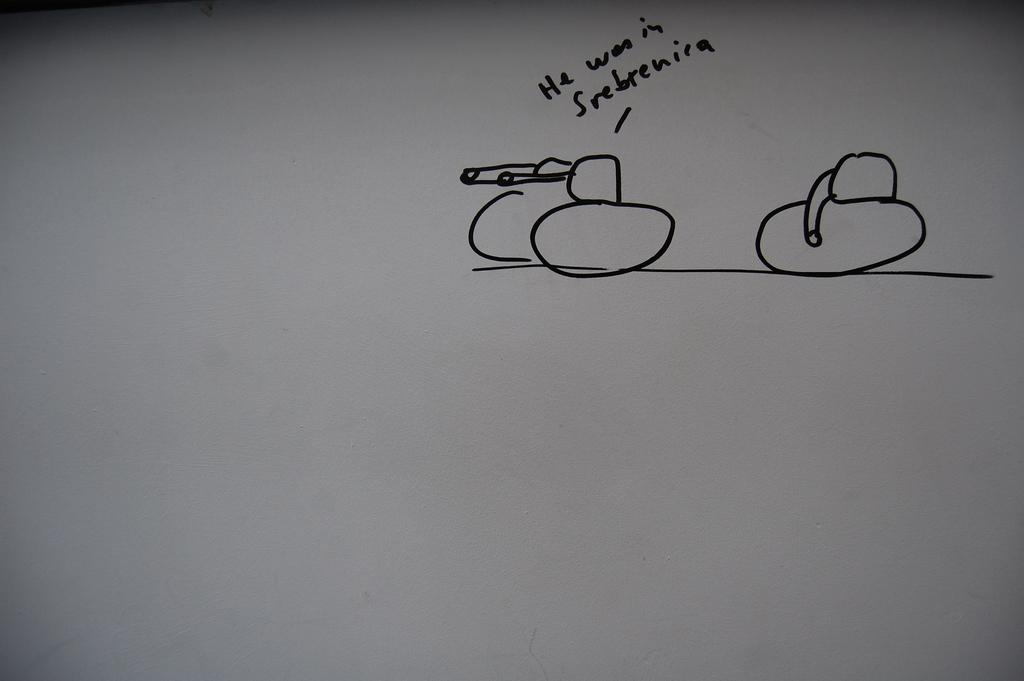<image>
Summarize the visual content of the image. White board which says "He won in Srebrenira". 